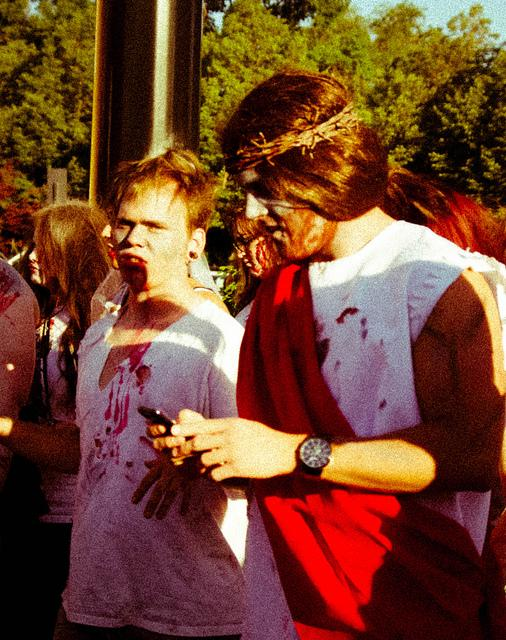What character does the man looking at his cell phone play?

Choices:
A) mary poppins
B) jesus
C) sweeny todd
D) santa jesus 